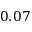Convert formula to latex. <formula><loc_0><loc_0><loc_500><loc_500>0 . 0 7</formula> 